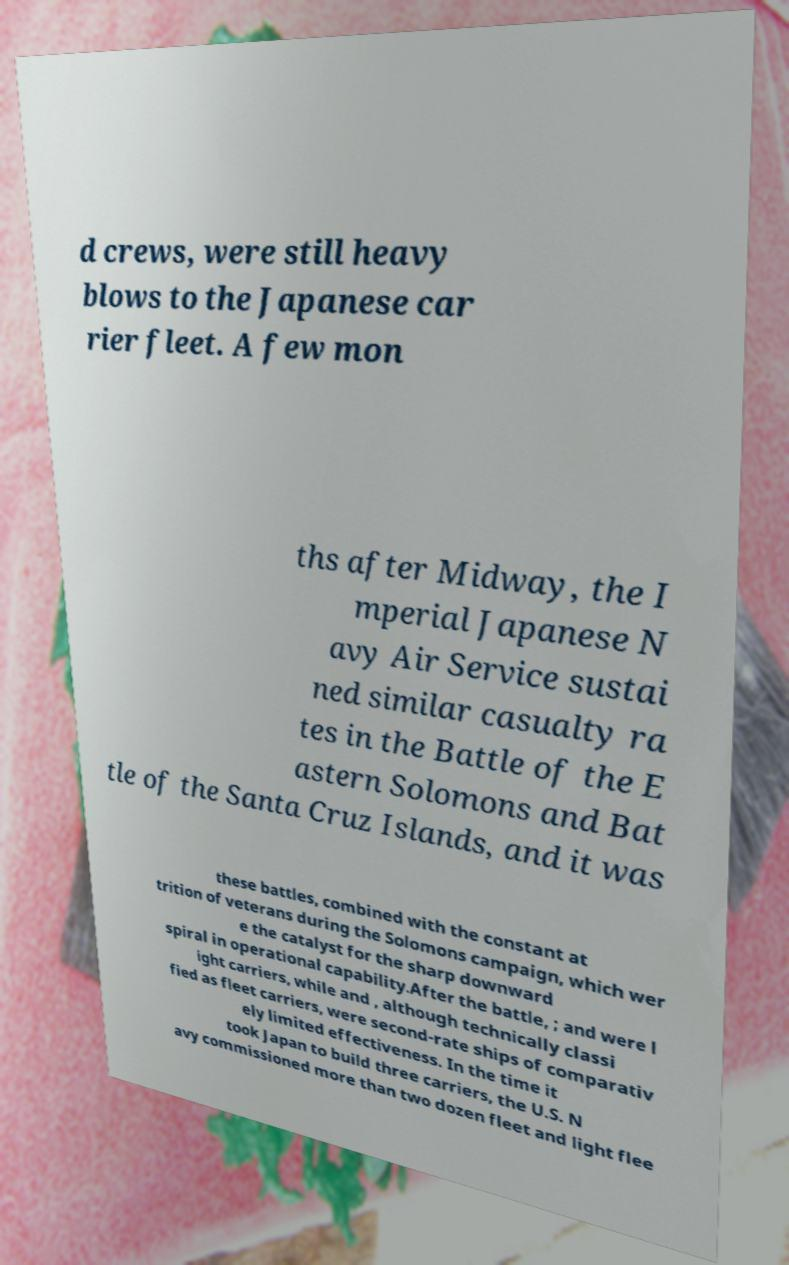Could you assist in decoding the text presented in this image and type it out clearly? d crews, were still heavy blows to the Japanese car rier fleet. A few mon ths after Midway, the I mperial Japanese N avy Air Service sustai ned similar casualty ra tes in the Battle of the E astern Solomons and Bat tle of the Santa Cruz Islands, and it was these battles, combined with the constant at trition of veterans during the Solomons campaign, which wer e the catalyst for the sharp downward spiral in operational capability.After the battle, ; and were l ight carriers, while and , although technically classi fied as fleet carriers, were second-rate ships of comparativ ely limited effectiveness. In the time it took Japan to build three carriers, the U.S. N avy commissioned more than two dozen fleet and light flee 